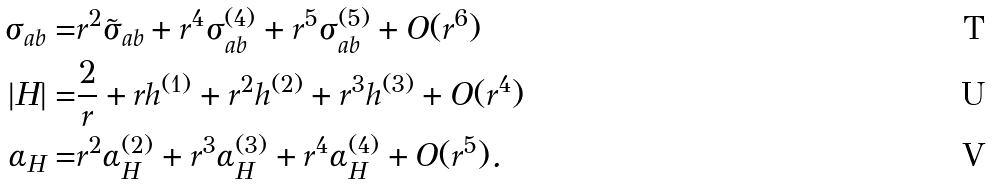<formula> <loc_0><loc_0><loc_500><loc_500>\sigma _ { a b } = & r ^ { 2 } \tilde { \sigma } _ { a b } + r ^ { 4 } \sigma _ { a b } ^ { ( 4 ) } + r ^ { 5 } \sigma _ { a b } ^ { ( 5 ) } + O ( r ^ { 6 } ) \\ | H | = & \frac { 2 } { r } + r h ^ { ( 1 ) } + r ^ { 2 } h ^ { ( 2 ) } + r ^ { 3 } h ^ { ( 3 ) } + O ( r ^ { 4 } ) \\ \alpha _ { H } = & r ^ { 2 } \alpha _ { H } ^ { ( 2 ) } + r ^ { 3 } \alpha _ { H } ^ { ( 3 ) } + r ^ { 4 } \alpha _ { H } ^ { ( 4 ) } + O ( r ^ { 5 } ) .</formula> 